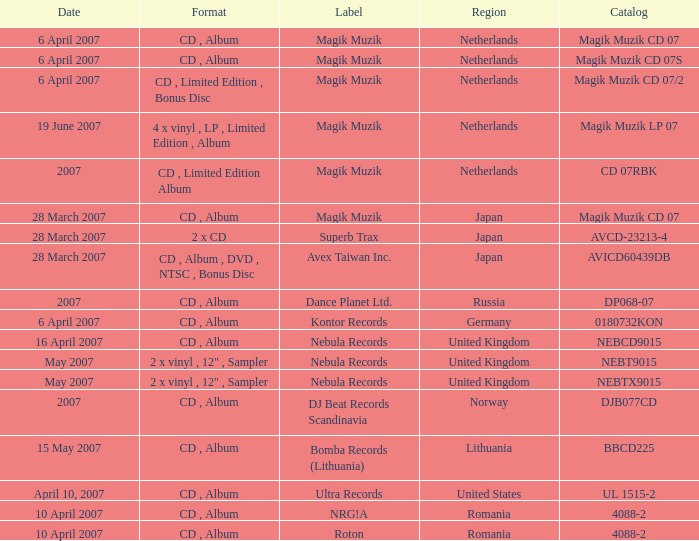For the catalog title DP068-07, what formats are available? CD , Album. 